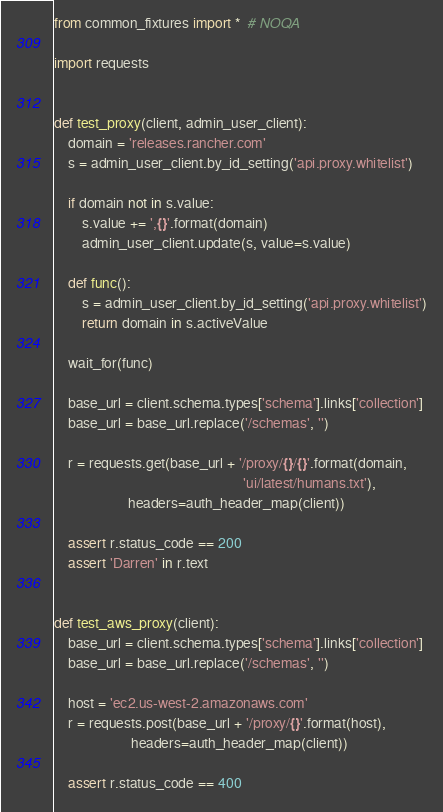<code> <loc_0><loc_0><loc_500><loc_500><_Python_>from common_fixtures import *  # NOQA

import requests


def test_proxy(client, admin_user_client):
    domain = 'releases.rancher.com'
    s = admin_user_client.by_id_setting('api.proxy.whitelist')

    if domain not in s.value:
        s.value += ',{}'.format(domain)
        admin_user_client.update(s, value=s.value)

    def func():
        s = admin_user_client.by_id_setting('api.proxy.whitelist')
        return domain in s.activeValue

    wait_for(func)

    base_url = client.schema.types['schema'].links['collection']
    base_url = base_url.replace('/schemas', '')

    r = requests.get(base_url + '/proxy/{}/{}'.format(domain,
                                                      'ui/latest/humans.txt'),
                     headers=auth_header_map(client))

    assert r.status_code == 200
    assert 'Darren' in r.text


def test_aws_proxy(client):
    base_url = client.schema.types['schema'].links['collection']
    base_url = base_url.replace('/schemas', '')

    host = 'ec2.us-west-2.amazonaws.com'
    r = requests.post(base_url + '/proxy/{}'.format(host),
                      headers=auth_header_map(client))

    assert r.status_code == 400
</code> 